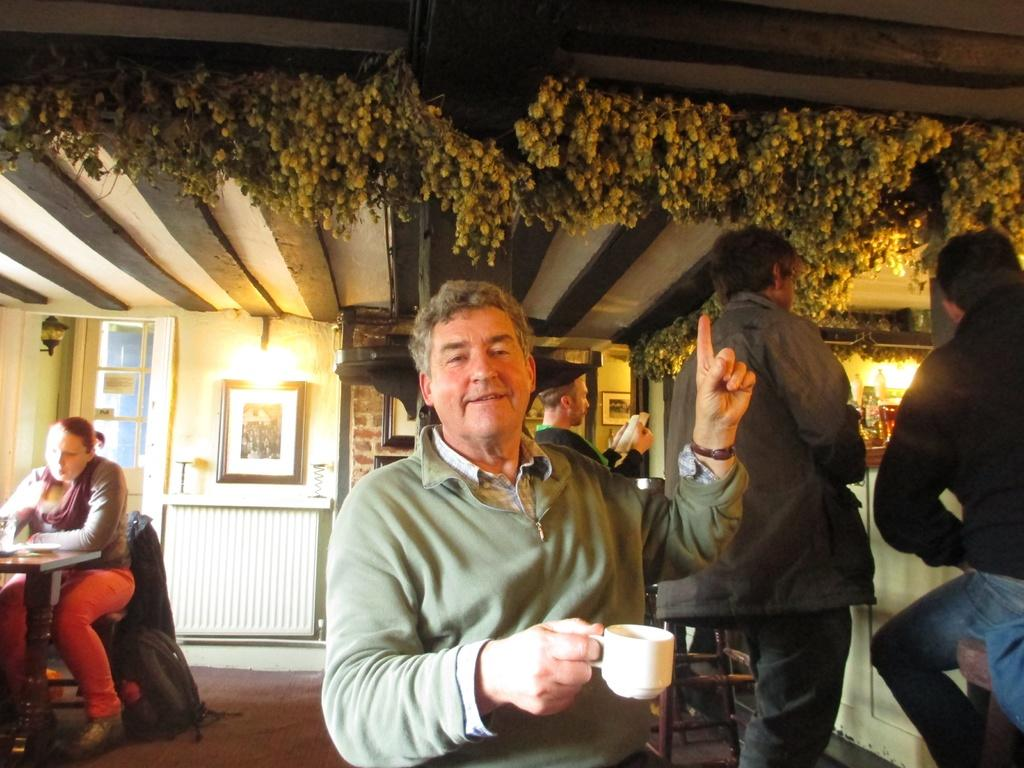What is the man in the image doing with his hand? The man is holding a cup with his hand. What is the man's facial expression in the image? The man is smiling. Can you describe the background of the image? There are people in the background of the image, as well as frames on the wall and lights visible. What type of pies can be seen in the man's underwear in the image? There is no mention of pies or underwear in the image; the man is holding a cup. What is the range of the lights visible in the background? The image does not provide information about the range of the lights; it only mentions that lights are visible in the background. 